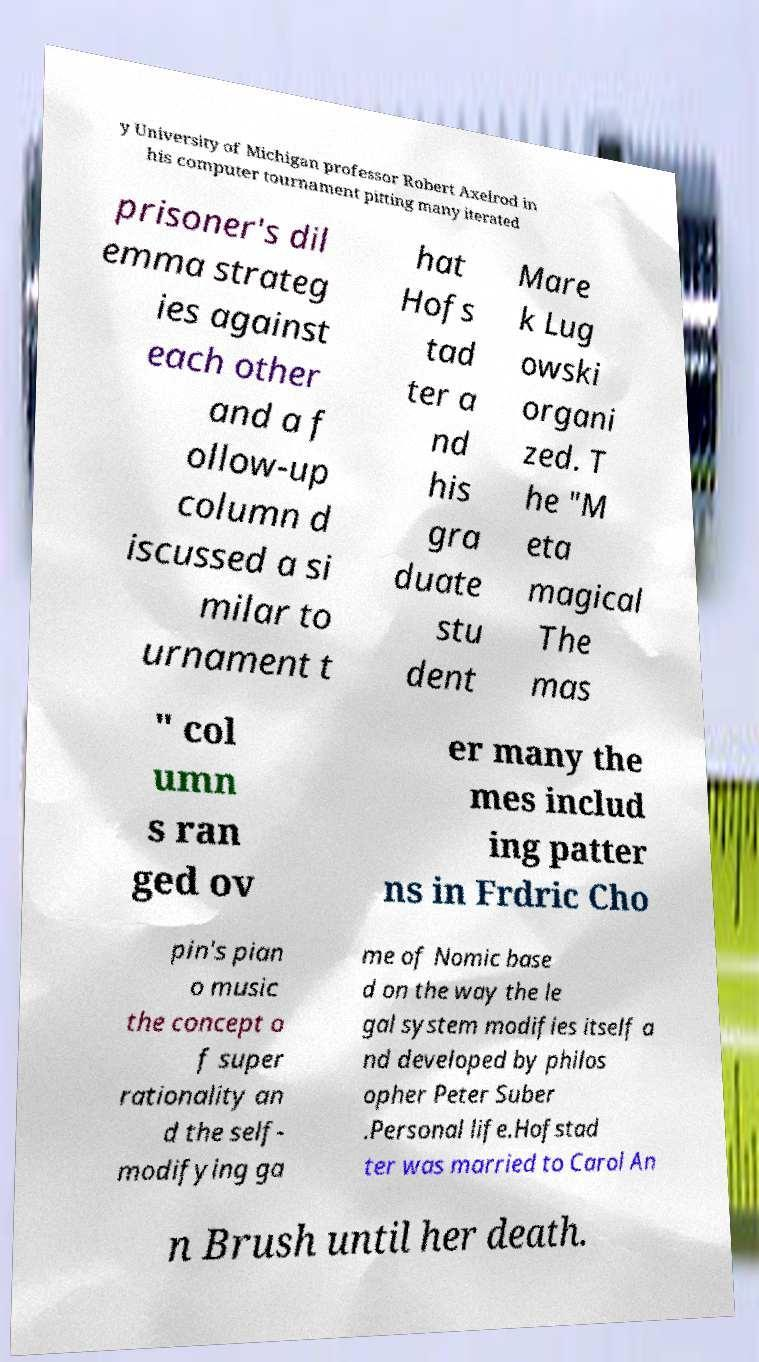Can you read and provide the text displayed in the image?This photo seems to have some interesting text. Can you extract and type it out for me? y University of Michigan professor Robert Axelrod in his computer tournament pitting many iterated prisoner's dil emma strateg ies against each other and a f ollow-up column d iscussed a si milar to urnament t hat Hofs tad ter a nd his gra duate stu dent Mare k Lug owski organi zed. T he "M eta magical The mas " col umn s ran ged ov er many the mes includ ing patter ns in Frdric Cho pin's pian o music the concept o f super rationality an d the self- modifying ga me of Nomic base d on the way the le gal system modifies itself a nd developed by philos opher Peter Suber .Personal life.Hofstad ter was married to Carol An n Brush until her death. 